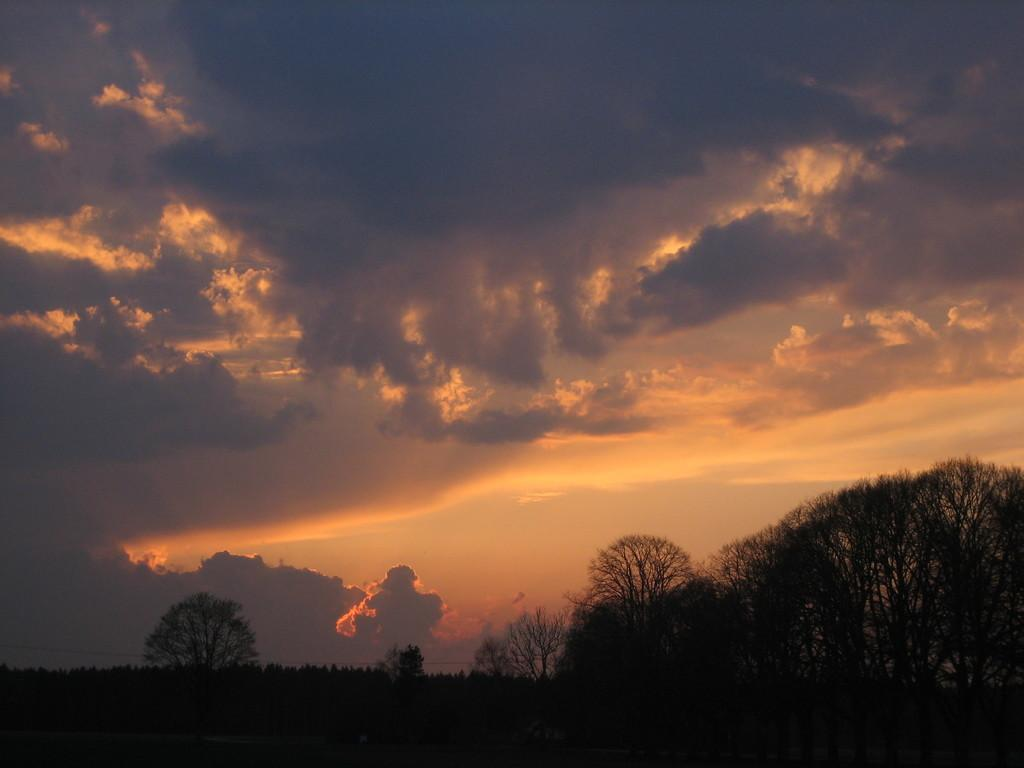What time of day was the image taken? The image was taken during the evening time. What type of natural environment is depicted in the image? There are many trees in the image, suggesting a forest or wooded area. What can be seen in the background of the image? The sky is visible in the background of the image. What is the condition of the sky in the image? There are clouds in the sky. How many chickens are visible in the image? There are no chickens present in the image. What type of fuel is being used by the trees in the image? Trees do not use fuel; they produce their own energy through photosynthesis. 